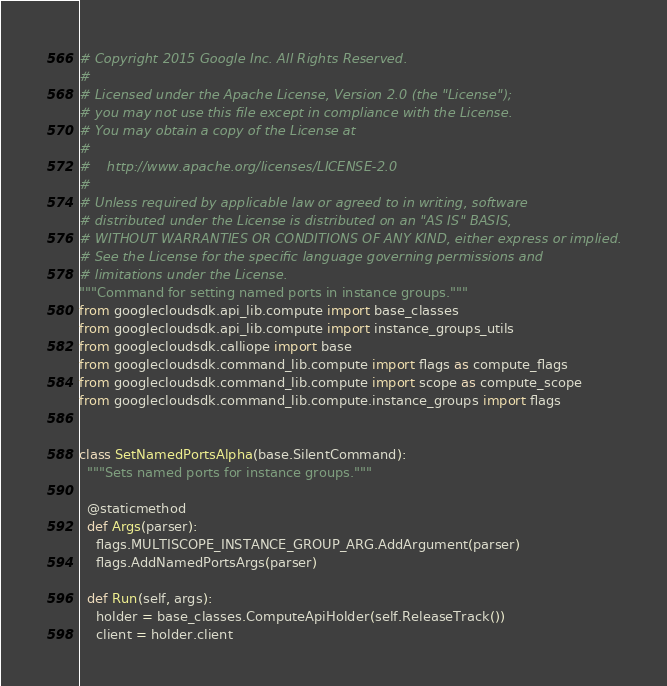<code> <loc_0><loc_0><loc_500><loc_500><_Python_># Copyright 2015 Google Inc. All Rights Reserved.
#
# Licensed under the Apache License, Version 2.0 (the "License");
# you may not use this file except in compliance with the License.
# You may obtain a copy of the License at
#
#    http://www.apache.org/licenses/LICENSE-2.0
#
# Unless required by applicable law or agreed to in writing, software
# distributed under the License is distributed on an "AS IS" BASIS,
# WITHOUT WARRANTIES OR CONDITIONS OF ANY KIND, either express or implied.
# See the License for the specific language governing permissions and
# limitations under the License.
"""Command for setting named ports in instance groups."""
from googlecloudsdk.api_lib.compute import base_classes
from googlecloudsdk.api_lib.compute import instance_groups_utils
from googlecloudsdk.calliope import base
from googlecloudsdk.command_lib.compute import flags as compute_flags
from googlecloudsdk.command_lib.compute import scope as compute_scope
from googlecloudsdk.command_lib.compute.instance_groups import flags


class SetNamedPortsAlpha(base.SilentCommand):
  """Sets named ports for instance groups."""

  @staticmethod
  def Args(parser):
    flags.MULTISCOPE_INSTANCE_GROUP_ARG.AddArgument(parser)
    flags.AddNamedPortsArgs(parser)

  def Run(self, args):
    holder = base_classes.ComputeApiHolder(self.ReleaseTrack())
    client = holder.client
</code> 